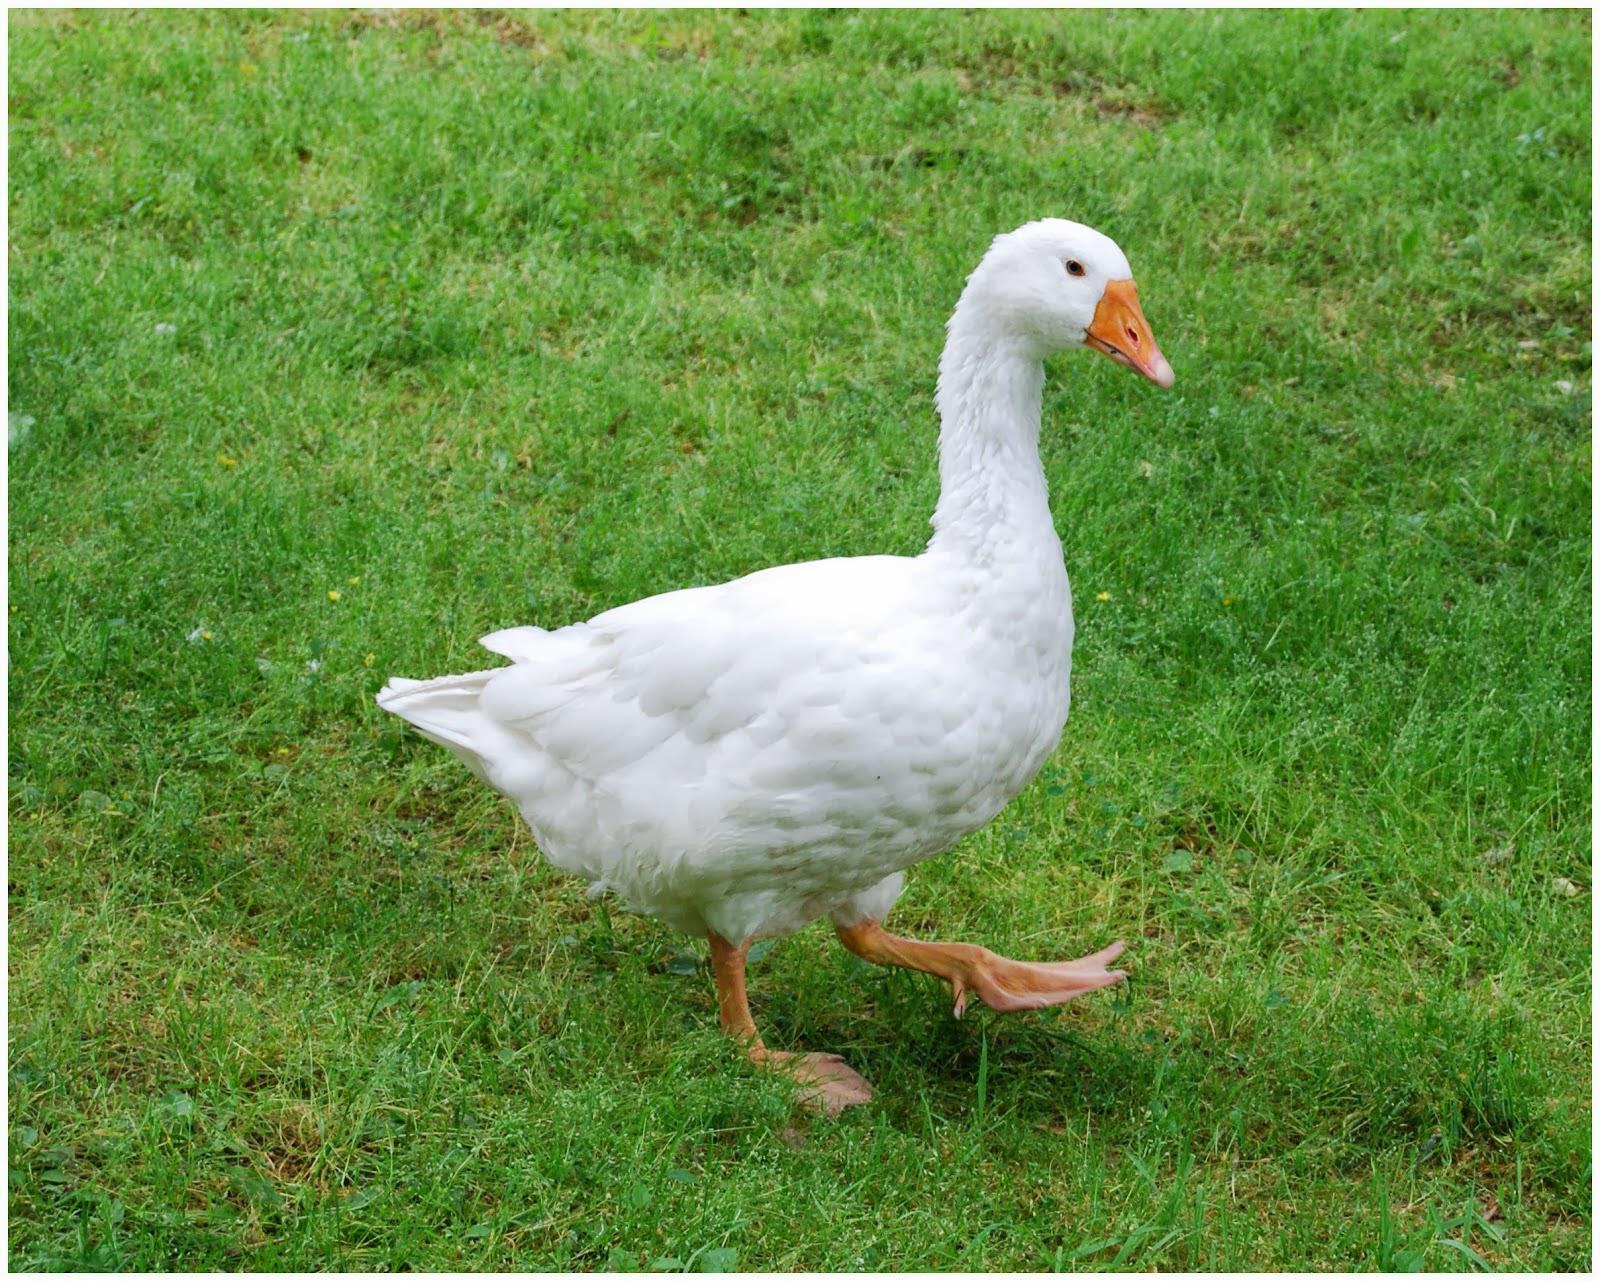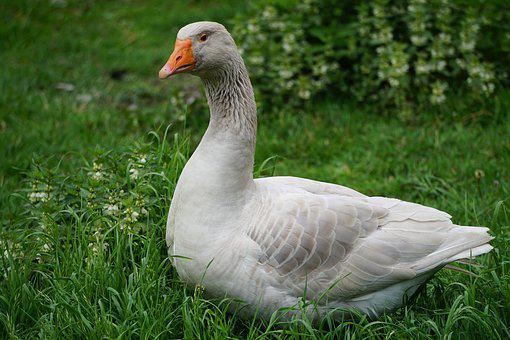The first image is the image on the left, the second image is the image on the right. Evaluate the accuracy of this statement regarding the images: "There are two geese". Is it true? Answer yes or no. Yes. 